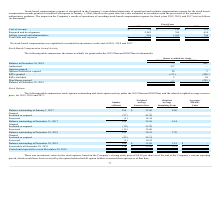From Quicklogic Corporation's financial document, What are the respective number of options forfeited or expired in the 2019 and 2009 plans? The document shows two values: 26 and 2 (in thousands). From the document: "Options forfeited or expired 26 2 Options forfeited or expired 26 2..." Also, What are the respective number of RSUs granted in the 2019 and 2009 plans? The document shows two values: 113 and 240 (in thousands). From the document: "RSUs granted (113 ) (240 ) RSUs granted (113 ) (240 )..." Also, What are the respective number of RSUs forfeited in the 2019 and 2009 plans? The document shows two values: 2 and 54 (in thousands). From the document: "RSUs forfeited 2 54 RSUs forfeited 2 54..." Also, can you calculate: What is the percentage change in the number of options forfeited or expired between the 2019 and 2009 plans? To answer this question, I need to perform calculations using the financial data. The calculation is: (26 - 2)/2 , which equals 1200 (percentage). This is based on the information: "Options forfeited or expired 26 2 Options forfeited or expired 26 2..." The key data points involved are: 26. Also, can you calculate: What is the percentage change in the number of RSUs granted between the 2019 and 2009 plans? To answer this question, I need to perform calculations using the financial data. The calculation is: (113 - 240)/240 , which equals -52.92 (percentage). This is based on the information: "RSUs granted (113 ) (240 ) RSUs granted (113 ) (240 )..." The key data points involved are: 113, 240. Also, can you calculate: What is the percentage change in the number of RSUs forfeited between the 2019 and 2009 plans? To answer this question, I need to perform calculations using the financial data. The calculation is: (2 - 54)/54  , which equals -96.3 (percentage). This is based on the information: "RSUs forfeited 2 54 RSUs forfeited 2 54..." The key data points involved are: 2, 54. 